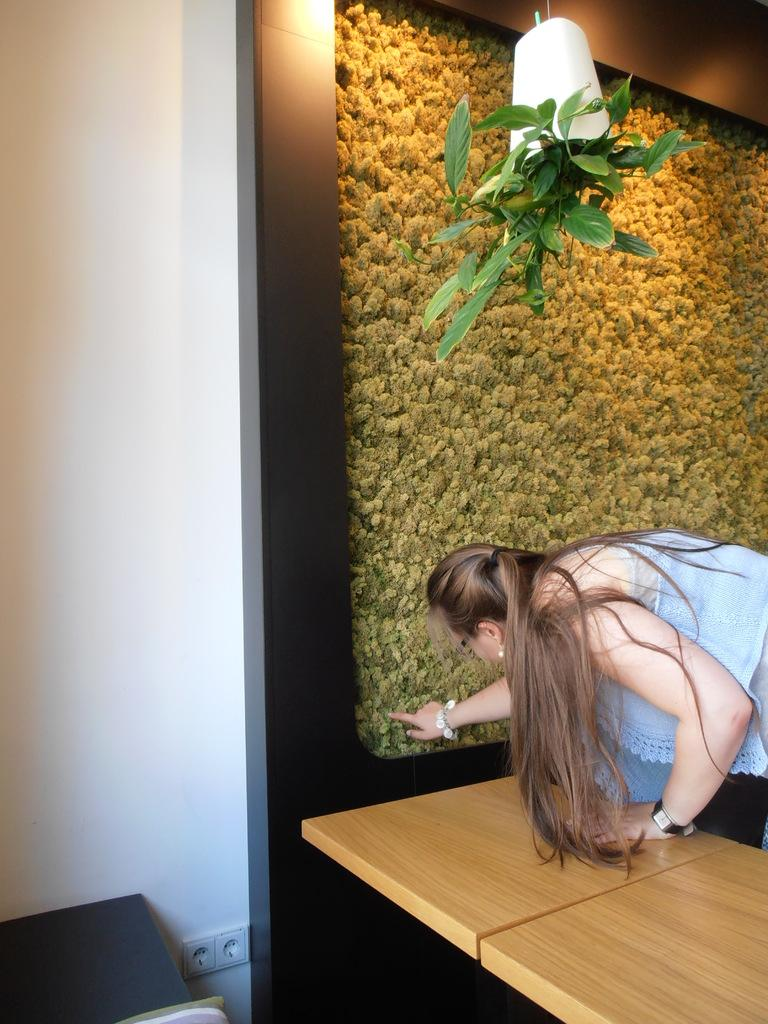Where is the lady located in the image? The lady is in the right corner of the image. What is in front of the lady? There is a table in front of the lady. What can be seen in the background of the image? There is a wall and a pot visible in the background of the image. What type of reaction does the lady have to the knot in the image? There is no knot present in the image, so it is not possible to determine the lady's reaction to it. 